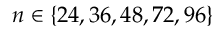<formula> <loc_0><loc_0><loc_500><loc_500>n \in \{ 2 4 , 3 6 , 4 8 , 7 2 , 9 6 \}</formula> 